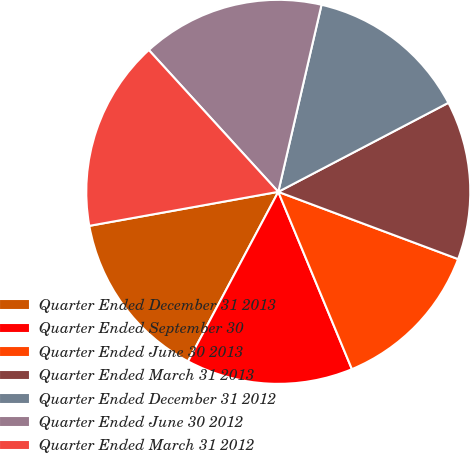Convert chart. <chart><loc_0><loc_0><loc_500><loc_500><pie_chart><fcel>Quarter Ended December 31 2013<fcel>Quarter Ended September 30<fcel>Quarter Ended June 30 2013<fcel>Quarter Ended March 31 2013<fcel>Quarter Ended December 31 2012<fcel>Quarter Ended June 30 2012<fcel>Quarter Ended March 31 2012<nl><fcel>14.38%<fcel>14.05%<fcel>13.04%<fcel>13.37%<fcel>13.71%<fcel>15.39%<fcel>16.06%<nl></chart> 